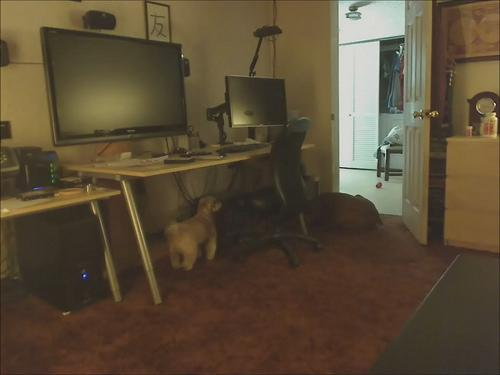Question: where was this photo taken?
Choices:
A. A bathroom.
B. A living room.
C. A garage.
D. A bedroom.
Answer with the letter. Answer: D Question: what color dog is under the table?
Choices:
A. Black.
B. Brown.
C. White.
D. Gray.
Answer with the letter. Answer: C Question: what color chair is by the monitors?
Choices:
A. Red.
B. Blue.
C. Black.
D. White.
Answer with the letter. Answer: C 